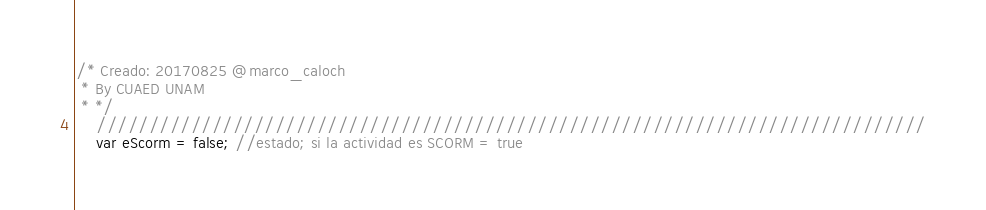Convert code to text. <code><loc_0><loc_0><loc_500><loc_500><_JavaScript_>/* Creado: 20170825 @marco_caloch
 * By CUAED UNAM
 * */
    ///////////////////////////////////////////////////////////////////////////////
    var eScorm = false; //estado; si la actividad es SCORM = true</code> 